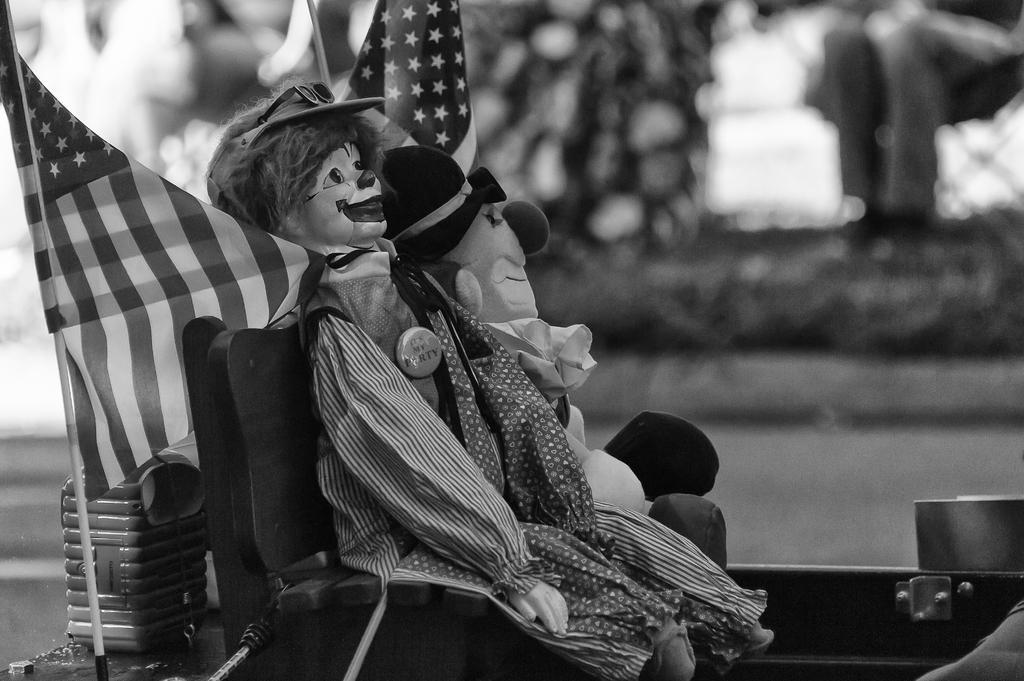Could you give a brief overview of what you see in this image? It is a black and white image. Here we can see toys, chairs, flags, stick and few objects. Background we can see the blur view. 